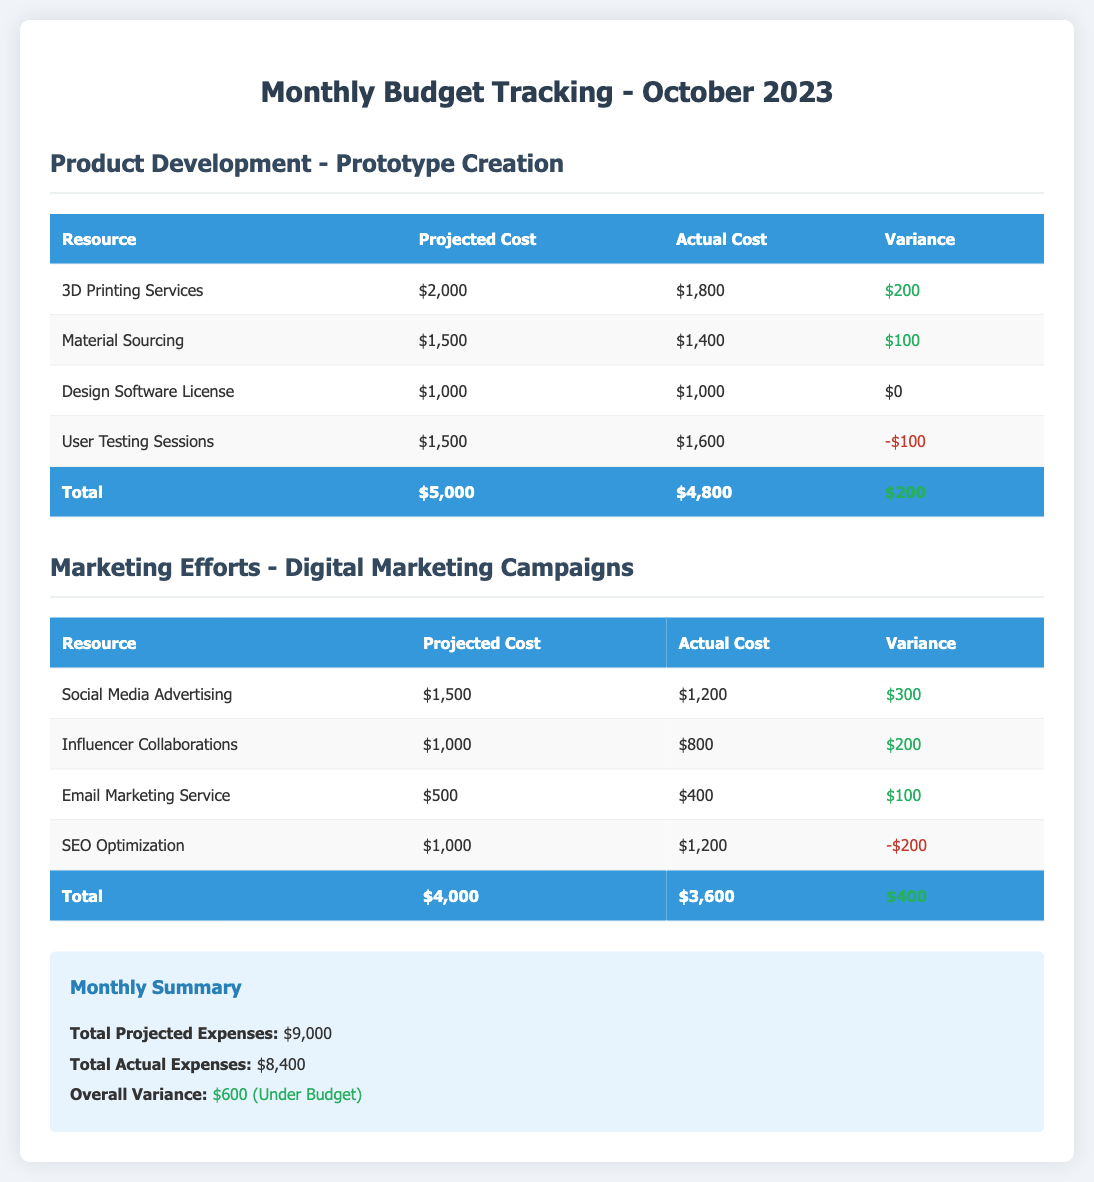what is the total projected expenses for Product Development? The total projected expenses for Product Development is $5,000.
Answer: $5,000 what is the actual cost of Social Media Advertising? The actual cost of Social Media Advertising is listed in the Marketing Efforts section, which shows $1,200.
Answer: $1,200 what is the variance for User Testing Sessions? The variance for User Testing Sessions is calculated by subtracting the Actual Cost from the Projected Cost, resulting in -$100.
Answer: -$100 what is the overall variance for the month? The overall variance for the month summarizes the difference between Total Projected Expenses and Total Actual Expenses, which is $600 (Under Budget).
Answer: $600 (Under Budget) how much was spent on Email Marketing Service? The actual expense for Email Marketing Service is shown in the document as $400.
Answer: $400 what is the total actual expenses for Marketing Efforts? The total actual expenses for Marketing Efforts is calculated as $3,600.
Answer: $3,600 how much was saved from the total budget this month? The total savings from the budget this month is found in the Overall Variance section, which indicates savings of $600.
Answer: $600 what was the projected cost for Design Software License? The projected cost for Design Software License is mentioned as $1,000.
Answer: $1,000 which resource had the largest positive variance? The resource with the largest positive variance is Social Media Advertising with a variance of $300.
Answer: Social Media Advertising what is the total projected cost for Digital Marketing Campaigns? The total projected cost for Digital Marketing Campaigns is the sum of individual projected costs, which is $4,000.
Answer: $4,000 